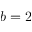Convert formula to latex. <formula><loc_0><loc_0><loc_500><loc_500>b = 2</formula> 